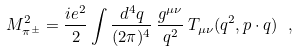Convert formula to latex. <formula><loc_0><loc_0><loc_500><loc_500>M ^ { 2 } _ { \pi ^ { \pm } } = \frac { i e ^ { 2 } } { 2 } \int \frac { d ^ { 4 } q } { ( 2 \pi ) ^ { 4 } } \, \frac { g ^ { \mu \nu } } { q ^ { 2 } } \, T _ { \mu \nu } ( q ^ { 2 } , p \cdot q ) \ ,</formula> 